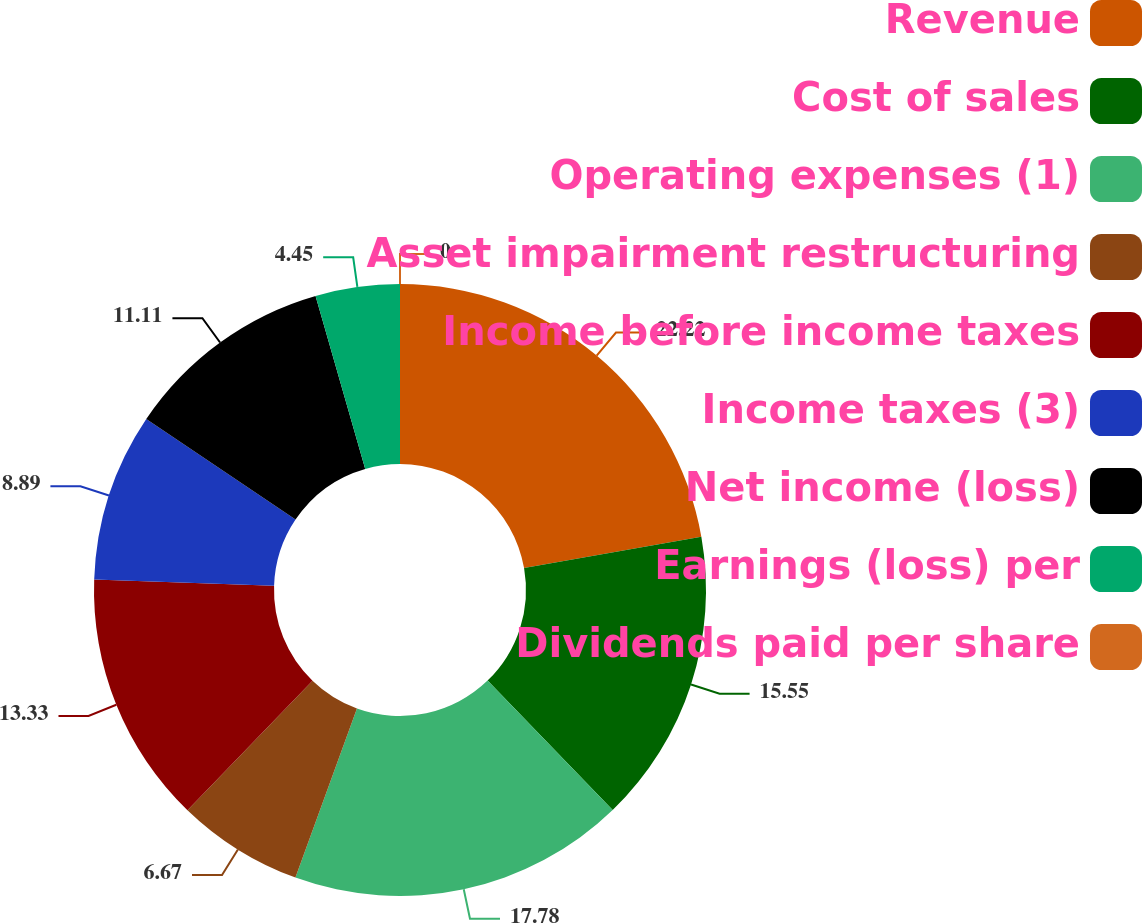Convert chart to OTSL. <chart><loc_0><loc_0><loc_500><loc_500><pie_chart><fcel>Revenue<fcel>Cost of sales<fcel>Operating expenses (1)<fcel>Asset impairment restructuring<fcel>Income before income taxes<fcel>Income taxes (3)<fcel>Net income (loss)<fcel>Earnings (loss) per<fcel>Dividends paid per share<nl><fcel>22.22%<fcel>15.55%<fcel>17.78%<fcel>6.67%<fcel>13.33%<fcel>8.89%<fcel>11.11%<fcel>4.45%<fcel>0.0%<nl></chart> 